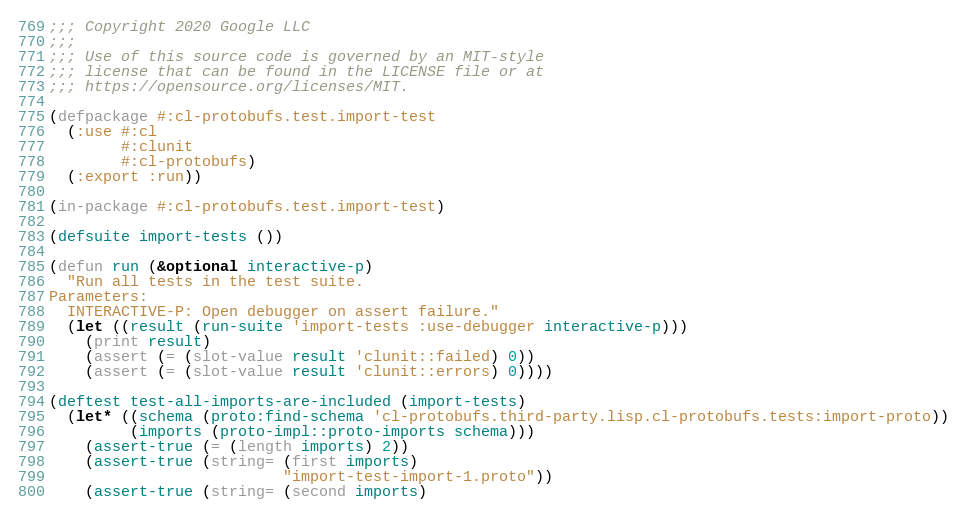Convert code to text. <code><loc_0><loc_0><loc_500><loc_500><_Lisp_>;;; Copyright 2020 Google LLC
;;;
;;; Use of this source code is governed by an MIT-style
;;; license that can be found in the LICENSE file or at
;;; https://opensource.org/licenses/MIT.

(defpackage #:cl-protobufs.test.import-test
  (:use #:cl
        #:clunit
        #:cl-protobufs)
  (:export :run))

(in-package #:cl-protobufs.test.import-test)

(defsuite import-tests ())

(defun run (&optional interactive-p)
  "Run all tests in the test suite.
Parameters:
  INTERACTIVE-P: Open debugger on assert failure."
  (let ((result (run-suite 'import-tests :use-debugger interactive-p)))
    (print result)
    (assert (= (slot-value result 'clunit::failed) 0))
    (assert (= (slot-value result 'clunit::errors) 0))))

(deftest test-all-imports-are-included (import-tests)
  (let* ((schema (proto:find-schema 'cl-protobufs.third-party.lisp.cl-protobufs.tests:import-proto))
         (imports (proto-impl::proto-imports schema)))
    (assert-true (= (length imports) 2))
    (assert-true (string= (first imports)
                          "import-test-import-1.proto"))
    (assert-true (string= (second imports)</code> 